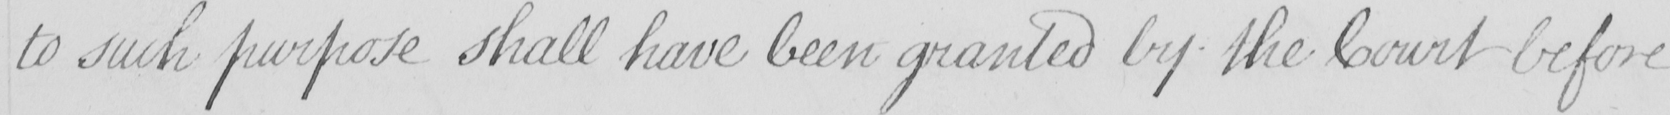What is written in this line of handwriting? to such purpose shall have been granted by the Court before 